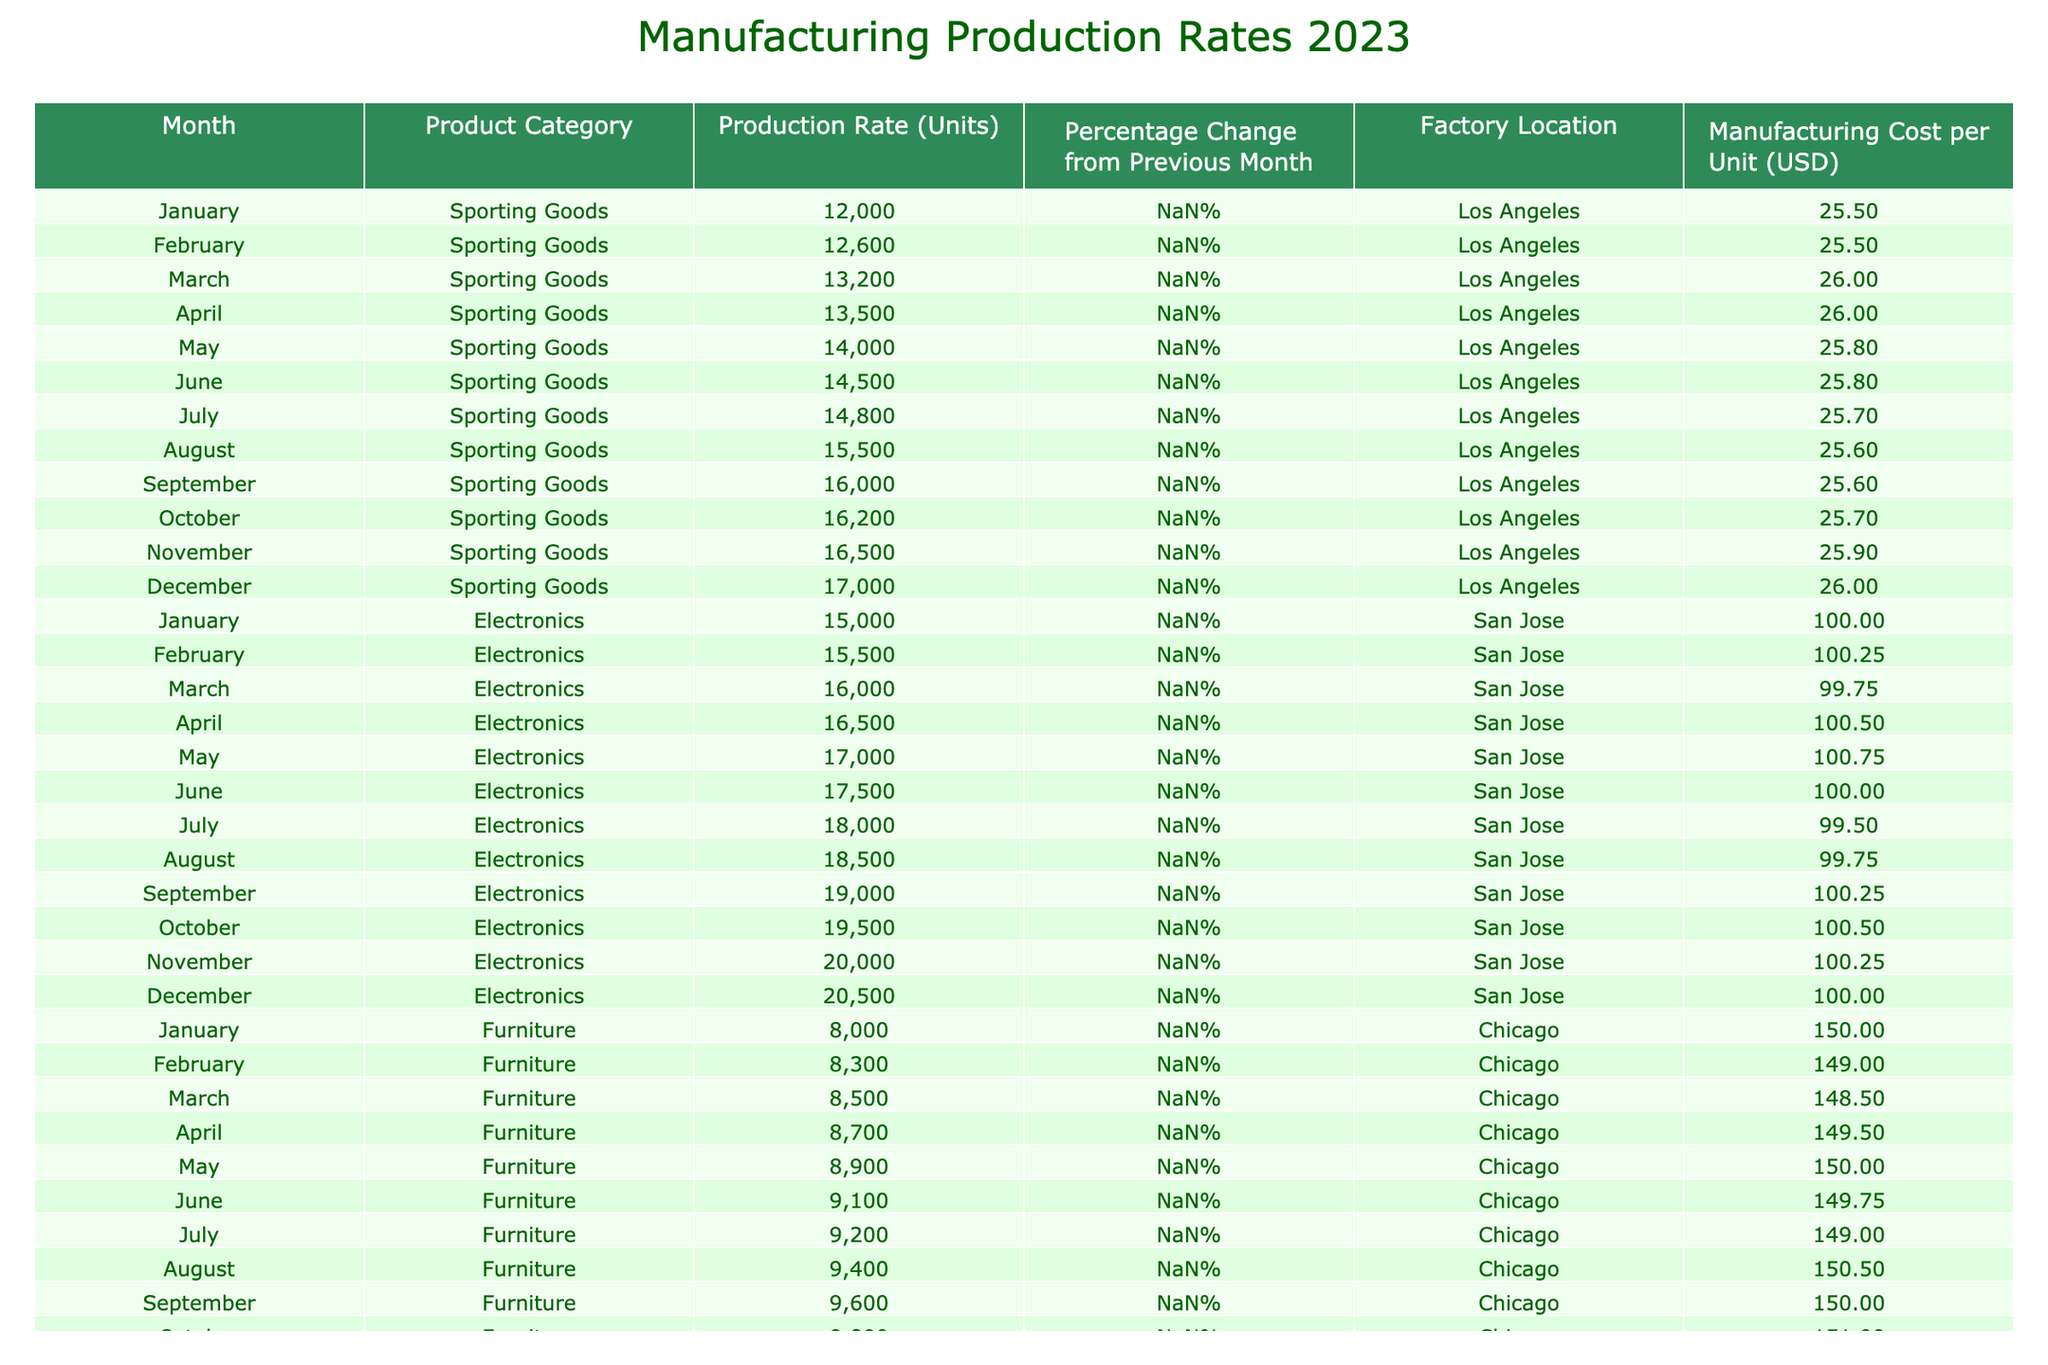What was the highest production rate for Sporting Goods in 2023? The highest production rate for Sporting Goods can be found by looking for the maximum value in the "Production Rate (Units)" column under the category "Sporting Goods." The highest value is 17,000 units in December.
Answer: 17,000 What was the average manufacturing cost per unit for Electronics in 2023? To find the average, sum the manufacturing costs for each month (100.00 + 100.25 + 99.75 + 100.50 + 100.75 + 100.00 + 99.50 + 99.75 + 100.25 + 100.50 + 100.25 + 100.00 = 1201.50) and then divide by the number of months (12). The average cost per unit is 1201.50 / 12 = 100.125.
Answer: 100.13 In which month did Furniture production see the largest percentage change compared to the previous month? To find the largest percentage change for Furniture, look at the "Percentage Change from Previous Month" column for the "Furniture" rows. The greatest change is 4.6% in January.
Answer: January Did the production rate for Electronics decrease at any point in 2023? By reviewing the "Production Rate (Units)" for Electronics month by month, we can see that it consistently increased and did not decrease at any point.
Answer: No What was the total production rate for Sporting Goods over the entire year? To find the total production rate for Sporting Goods, sum the monthly production rates: (12000 + 12600 + 13200 + 13500 + 14000 + 14500 + 14800 + 15500 + 16000 + 16200 + 16500 + 17000 = 177,800 units).
Answer: 177,800 Which product category had the lowest production rate in any month, and what was that rate? Look through the production rates for all categories, and the lowest value is 8,000 units for Furniture in January.
Answer: 8,000 What was the percentage change from November to December for Sporting Goods? To calculate this, take the December production rate (17,000) minus the November production rate (16,500), divide by November (16,500), and multiply by 100. The percentage change is ((17,000 - 16,500) / 16,500) * 100 = 3.0%.
Answer: 3.0% In how many months did the manufacturing cost per unit for Furniture increase? Examine the "Manufacturing Cost per Unit (USD)" for Furniture month to month. The costs increased from February to April (149.00 to 149.50) and then again from July to August (149.00 to 150.50), totaling four months of increase.
Answer: 4 months What was the total production for Electronics during the last quarter of 2023? The last quarter includes October (19,500), November (20,000), and December (20,500), so the total production is 19,500 + 20,000 + 20,500 = 60,000 units.
Answer: 60,000 How much did the production rate of Sporting Goods grow from January to December? The growth is determined by subtracting the January production rate (12,000) from the December production rate (17,000). Therefore, the growth is 17,000 - 12,000 = 5,000 units.
Answer: 5,000 Was the average production rate for Furniture higher than the average for Sporting Goods in 2023? First, compute the average production rate for both categories. Sporting Goods average is (177,800 / 12) = 14,816.67 units, while Furniture is (103,200 / 12) = 8,600 units. Since 14,816.67 > 8,600, the answer is no.
Answer: No 